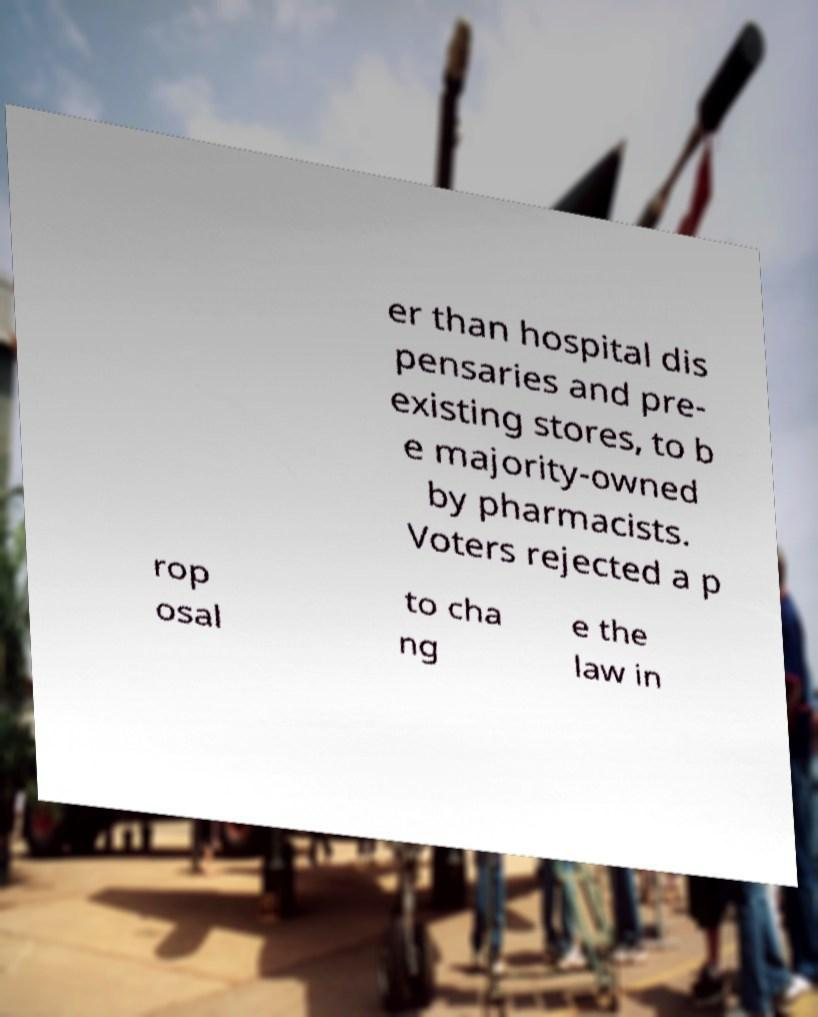There's text embedded in this image that I need extracted. Can you transcribe it verbatim? er than hospital dis pensaries and pre- existing stores, to b e majority-owned by pharmacists. Voters rejected a p rop osal to cha ng e the law in 